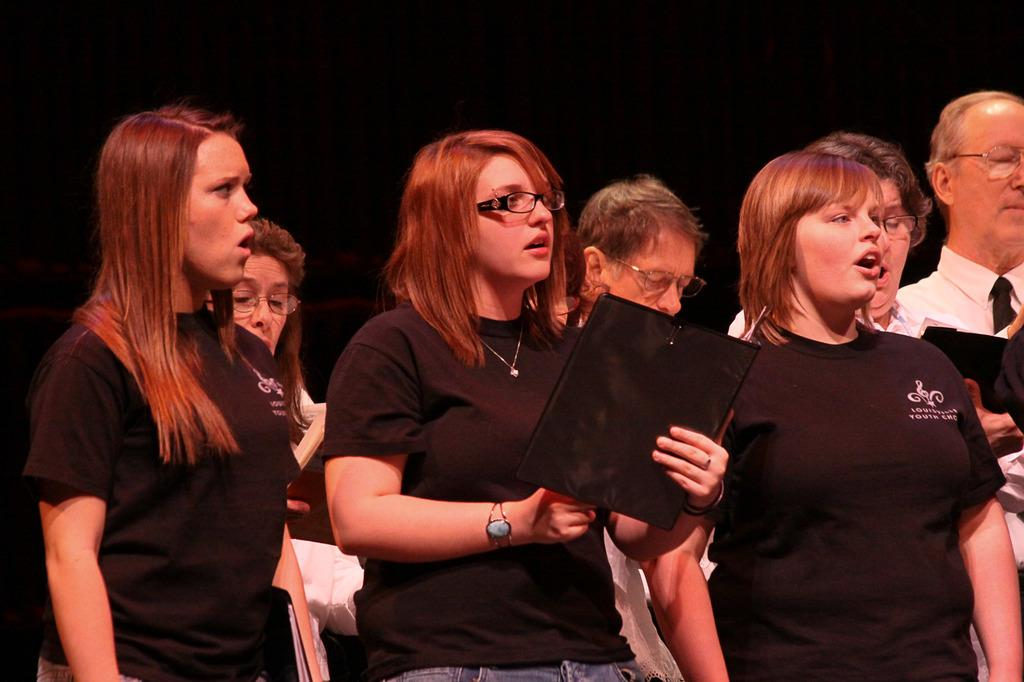What are the women in the image wearing? The women in the image are wearing black dresses. Where are the women positioned in the image? The women are standing in the front. What are the women doing in the image? The women are singing. What can be seen behind the women in the image? There are persons in white dress behind the women. What is the color of the background in the image? The background of the image is black. Can you see any dinosaurs in the image? No, there are no dinosaurs present in the image. What type of ocean can be seen in the background of the image? There is no ocean visible in the image; the background is black. 